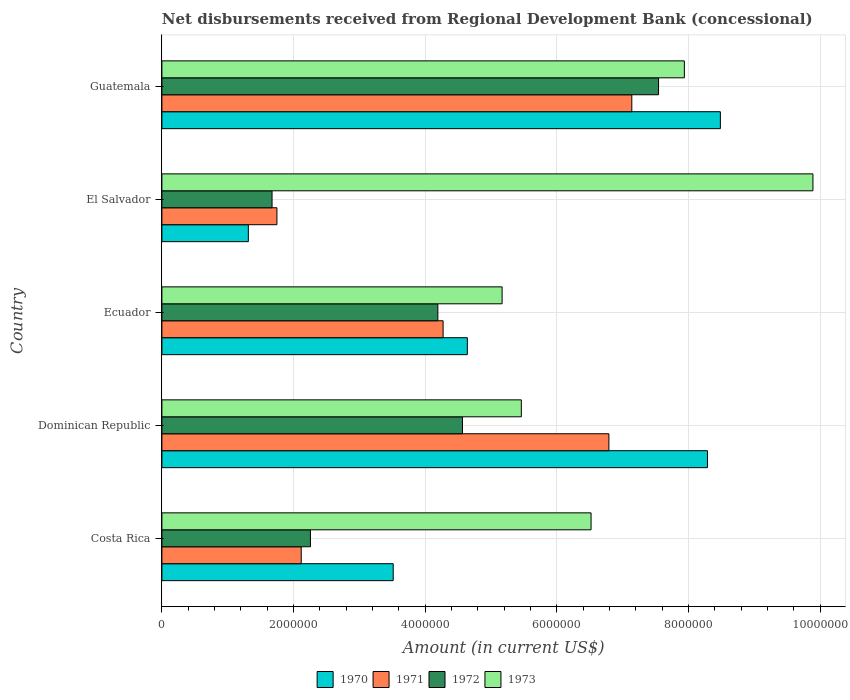How many groups of bars are there?
Give a very brief answer. 5. What is the label of the 1st group of bars from the top?
Make the answer very short. Guatemala. In how many cases, is the number of bars for a given country not equal to the number of legend labels?
Give a very brief answer. 0. What is the amount of disbursements received from Regional Development Bank in 1973 in Dominican Republic?
Keep it short and to the point. 5.46e+06. Across all countries, what is the maximum amount of disbursements received from Regional Development Bank in 1973?
Your response must be concise. 9.89e+06. Across all countries, what is the minimum amount of disbursements received from Regional Development Bank in 1973?
Provide a short and direct response. 5.17e+06. In which country was the amount of disbursements received from Regional Development Bank in 1973 maximum?
Offer a terse response. El Salvador. In which country was the amount of disbursements received from Regional Development Bank in 1971 minimum?
Make the answer very short. El Salvador. What is the total amount of disbursements received from Regional Development Bank in 1973 in the graph?
Ensure brevity in your answer.  3.50e+07. What is the difference between the amount of disbursements received from Regional Development Bank in 1973 in Costa Rica and that in Dominican Republic?
Offer a very short reply. 1.06e+06. What is the difference between the amount of disbursements received from Regional Development Bank in 1973 in Dominican Republic and the amount of disbursements received from Regional Development Bank in 1971 in El Salvador?
Your response must be concise. 3.71e+06. What is the average amount of disbursements received from Regional Development Bank in 1971 per country?
Your answer should be compact. 4.41e+06. What is the difference between the amount of disbursements received from Regional Development Bank in 1972 and amount of disbursements received from Regional Development Bank in 1970 in Guatemala?
Give a very brief answer. -9.39e+05. What is the ratio of the amount of disbursements received from Regional Development Bank in 1973 in El Salvador to that in Guatemala?
Provide a short and direct response. 1.25. Is the amount of disbursements received from Regional Development Bank in 1972 in Costa Rica less than that in Guatemala?
Give a very brief answer. Yes. Is the difference between the amount of disbursements received from Regional Development Bank in 1972 in Dominican Republic and El Salvador greater than the difference between the amount of disbursements received from Regional Development Bank in 1970 in Dominican Republic and El Salvador?
Your answer should be compact. No. What is the difference between the highest and the second highest amount of disbursements received from Regional Development Bank in 1973?
Provide a short and direct response. 1.95e+06. What is the difference between the highest and the lowest amount of disbursements received from Regional Development Bank in 1972?
Ensure brevity in your answer.  5.87e+06. In how many countries, is the amount of disbursements received from Regional Development Bank in 1970 greater than the average amount of disbursements received from Regional Development Bank in 1970 taken over all countries?
Your response must be concise. 2. Is it the case that in every country, the sum of the amount of disbursements received from Regional Development Bank in 1971 and amount of disbursements received from Regional Development Bank in 1972 is greater than the amount of disbursements received from Regional Development Bank in 1973?
Provide a succinct answer. No. How many bars are there?
Offer a terse response. 20. What is the difference between two consecutive major ticks on the X-axis?
Provide a succinct answer. 2.00e+06. Does the graph contain any zero values?
Provide a short and direct response. No. Where does the legend appear in the graph?
Offer a very short reply. Bottom center. How many legend labels are there?
Keep it short and to the point. 4. What is the title of the graph?
Your response must be concise. Net disbursements received from Regional Development Bank (concessional). What is the label or title of the X-axis?
Your answer should be compact. Amount (in current US$). What is the label or title of the Y-axis?
Provide a succinct answer. Country. What is the Amount (in current US$) in 1970 in Costa Rica?
Give a very brief answer. 3.51e+06. What is the Amount (in current US$) of 1971 in Costa Rica?
Give a very brief answer. 2.12e+06. What is the Amount (in current US$) in 1972 in Costa Rica?
Offer a terse response. 2.26e+06. What is the Amount (in current US$) in 1973 in Costa Rica?
Your answer should be compact. 6.52e+06. What is the Amount (in current US$) of 1970 in Dominican Republic?
Offer a terse response. 8.29e+06. What is the Amount (in current US$) of 1971 in Dominican Republic?
Provide a succinct answer. 6.79e+06. What is the Amount (in current US$) of 1972 in Dominican Republic?
Ensure brevity in your answer.  4.56e+06. What is the Amount (in current US$) of 1973 in Dominican Republic?
Give a very brief answer. 5.46e+06. What is the Amount (in current US$) of 1970 in Ecuador?
Ensure brevity in your answer.  4.64e+06. What is the Amount (in current US$) of 1971 in Ecuador?
Keep it short and to the point. 4.27e+06. What is the Amount (in current US$) of 1972 in Ecuador?
Your response must be concise. 4.19e+06. What is the Amount (in current US$) of 1973 in Ecuador?
Keep it short and to the point. 5.17e+06. What is the Amount (in current US$) in 1970 in El Salvador?
Give a very brief answer. 1.31e+06. What is the Amount (in current US$) in 1971 in El Salvador?
Offer a terse response. 1.75e+06. What is the Amount (in current US$) in 1972 in El Salvador?
Give a very brief answer. 1.67e+06. What is the Amount (in current US$) of 1973 in El Salvador?
Keep it short and to the point. 9.89e+06. What is the Amount (in current US$) in 1970 in Guatemala?
Your response must be concise. 8.48e+06. What is the Amount (in current US$) in 1971 in Guatemala?
Your answer should be very brief. 7.14e+06. What is the Amount (in current US$) in 1972 in Guatemala?
Your answer should be very brief. 7.54e+06. What is the Amount (in current US$) of 1973 in Guatemala?
Offer a terse response. 7.94e+06. Across all countries, what is the maximum Amount (in current US$) of 1970?
Ensure brevity in your answer.  8.48e+06. Across all countries, what is the maximum Amount (in current US$) in 1971?
Keep it short and to the point. 7.14e+06. Across all countries, what is the maximum Amount (in current US$) of 1972?
Offer a very short reply. 7.54e+06. Across all countries, what is the maximum Amount (in current US$) in 1973?
Give a very brief answer. 9.89e+06. Across all countries, what is the minimum Amount (in current US$) in 1970?
Give a very brief answer. 1.31e+06. Across all countries, what is the minimum Amount (in current US$) in 1971?
Keep it short and to the point. 1.75e+06. Across all countries, what is the minimum Amount (in current US$) of 1972?
Ensure brevity in your answer.  1.67e+06. Across all countries, what is the minimum Amount (in current US$) of 1973?
Give a very brief answer. 5.17e+06. What is the total Amount (in current US$) of 1970 in the graph?
Offer a terse response. 2.62e+07. What is the total Amount (in current US$) of 1971 in the graph?
Make the answer very short. 2.21e+07. What is the total Amount (in current US$) of 1972 in the graph?
Provide a succinct answer. 2.02e+07. What is the total Amount (in current US$) in 1973 in the graph?
Offer a very short reply. 3.50e+07. What is the difference between the Amount (in current US$) in 1970 in Costa Rica and that in Dominican Republic?
Make the answer very short. -4.77e+06. What is the difference between the Amount (in current US$) in 1971 in Costa Rica and that in Dominican Republic?
Your answer should be very brief. -4.67e+06. What is the difference between the Amount (in current US$) in 1972 in Costa Rica and that in Dominican Republic?
Offer a terse response. -2.31e+06. What is the difference between the Amount (in current US$) in 1973 in Costa Rica and that in Dominican Republic?
Provide a short and direct response. 1.06e+06. What is the difference between the Amount (in current US$) of 1970 in Costa Rica and that in Ecuador?
Make the answer very short. -1.13e+06. What is the difference between the Amount (in current US$) in 1971 in Costa Rica and that in Ecuador?
Ensure brevity in your answer.  -2.16e+06. What is the difference between the Amount (in current US$) of 1972 in Costa Rica and that in Ecuador?
Make the answer very short. -1.94e+06. What is the difference between the Amount (in current US$) in 1973 in Costa Rica and that in Ecuador?
Give a very brief answer. 1.35e+06. What is the difference between the Amount (in current US$) in 1970 in Costa Rica and that in El Salvador?
Keep it short and to the point. 2.20e+06. What is the difference between the Amount (in current US$) in 1971 in Costa Rica and that in El Salvador?
Provide a succinct answer. 3.69e+05. What is the difference between the Amount (in current US$) in 1972 in Costa Rica and that in El Salvador?
Keep it short and to the point. 5.83e+05. What is the difference between the Amount (in current US$) of 1973 in Costa Rica and that in El Salvador?
Your response must be concise. -3.37e+06. What is the difference between the Amount (in current US$) in 1970 in Costa Rica and that in Guatemala?
Your answer should be very brief. -4.97e+06. What is the difference between the Amount (in current US$) in 1971 in Costa Rica and that in Guatemala?
Make the answer very short. -5.02e+06. What is the difference between the Amount (in current US$) of 1972 in Costa Rica and that in Guatemala?
Make the answer very short. -5.29e+06. What is the difference between the Amount (in current US$) in 1973 in Costa Rica and that in Guatemala?
Offer a terse response. -1.42e+06. What is the difference between the Amount (in current US$) in 1970 in Dominican Republic and that in Ecuador?
Offer a very short reply. 3.65e+06. What is the difference between the Amount (in current US$) in 1971 in Dominican Republic and that in Ecuador?
Your answer should be very brief. 2.52e+06. What is the difference between the Amount (in current US$) in 1972 in Dominican Republic and that in Ecuador?
Give a very brief answer. 3.74e+05. What is the difference between the Amount (in current US$) of 1973 in Dominican Republic and that in Ecuador?
Offer a terse response. 2.92e+05. What is the difference between the Amount (in current US$) in 1970 in Dominican Republic and that in El Salvador?
Offer a very short reply. 6.97e+06. What is the difference between the Amount (in current US$) of 1971 in Dominican Republic and that in El Salvador?
Offer a terse response. 5.04e+06. What is the difference between the Amount (in current US$) of 1972 in Dominican Republic and that in El Salvador?
Your response must be concise. 2.89e+06. What is the difference between the Amount (in current US$) in 1973 in Dominican Republic and that in El Salvador?
Your answer should be compact. -4.43e+06. What is the difference between the Amount (in current US$) of 1970 in Dominican Republic and that in Guatemala?
Give a very brief answer. -1.96e+05. What is the difference between the Amount (in current US$) in 1971 in Dominican Republic and that in Guatemala?
Your answer should be very brief. -3.48e+05. What is the difference between the Amount (in current US$) in 1972 in Dominican Republic and that in Guatemala?
Provide a short and direct response. -2.98e+06. What is the difference between the Amount (in current US$) of 1973 in Dominican Republic and that in Guatemala?
Make the answer very short. -2.48e+06. What is the difference between the Amount (in current US$) in 1970 in Ecuador and that in El Salvador?
Your answer should be very brief. 3.33e+06. What is the difference between the Amount (in current US$) of 1971 in Ecuador and that in El Salvador?
Ensure brevity in your answer.  2.52e+06. What is the difference between the Amount (in current US$) in 1972 in Ecuador and that in El Salvador?
Offer a terse response. 2.52e+06. What is the difference between the Amount (in current US$) in 1973 in Ecuador and that in El Salvador?
Ensure brevity in your answer.  -4.72e+06. What is the difference between the Amount (in current US$) in 1970 in Ecuador and that in Guatemala?
Ensure brevity in your answer.  -3.84e+06. What is the difference between the Amount (in current US$) in 1971 in Ecuador and that in Guatemala?
Offer a very short reply. -2.87e+06. What is the difference between the Amount (in current US$) in 1972 in Ecuador and that in Guatemala?
Offer a very short reply. -3.35e+06. What is the difference between the Amount (in current US$) in 1973 in Ecuador and that in Guatemala?
Offer a terse response. -2.77e+06. What is the difference between the Amount (in current US$) in 1970 in El Salvador and that in Guatemala?
Your answer should be very brief. -7.17e+06. What is the difference between the Amount (in current US$) in 1971 in El Salvador and that in Guatemala?
Make the answer very short. -5.39e+06. What is the difference between the Amount (in current US$) in 1972 in El Salvador and that in Guatemala?
Your answer should be very brief. -5.87e+06. What is the difference between the Amount (in current US$) of 1973 in El Salvador and that in Guatemala?
Your response must be concise. 1.95e+06. What is the difference between the Amount (in current US$) in 1970 in Costa Rica and the Amount (in current US$) in 1971 in Dominican Republic?
Provide a succinct answer. -3.28e+06. What is the difference between the Amount (in current US$) of 1970 in Costa Rica and the Amount (in current US$) of 1972 in Dominican Republic?
Your answer should be very brief. -1.05e+06. What is the difference between the Amount (in current US$) of 1970 in Costa Rica and the Amount (in current US$) of 1973 in Dominican Republic?
Your answer should be compact. -1.95e+06. What is the difference between the Amount (in current US$) in 1971 in Costa Rica and the Amount (in current US$) in 1972 in Dominican Republic?
Give a very brief answer. -2.45e+06. What is the difference between the Amount (in current US$) in 1971 in Costa Rica and the Amount (in current US$) in 1973 in Dominican Republic?
Ensure brevity in your answer.  -3.34e+06. What is the difference between the Amount (in current US$) in 1972 in Costa Rica and the Amount (in current US$) in 1973 in Dominican Republic?
Give a very brief answer. -3.20e+06. What is the difference between the Amount (in current US$) of 1970 in Costa Rica and the Amount (in current US$) of 1971 in Ecuador?
Give a very brief answer. -7.58e+05. What is the difference between the Amount (in current US$) of 1970 in Costa Rica and the Amount (in current US$) of 1972 in Ecuador?
Your answer should be very brief. -6.78e+05. What is the difference between the Amount (in current US$) in 1970 in Costa Rica and the Amount (in current US$) in 1973 in Ecuador?
Ensure brevity in your answer.  -1.65e+06. What is the difference between the Amount (in current US$) in 1971 in Costa Rica and the Amount (in current US$) in 1972 in Ecuador?
Offer a very short reply. -2.08e+06. What is the difference between the Amount (in current US$) in 1971 in Costa Rica and the Amount (in current US$) in 1973 in Ecuador?
Offer a terse response. -3.05e+06. What is the difference between the Amount (in current US$) of 1972 in Costa Rica and the Amount (in current US$) of 1973 in Ecuador?
Your response must be concise. -2.91e+06. What is the difference between the Amount (in current US$) in 1970 in Costa Rica and the Amount (in current US$) in 1971 in El Salvador?
Keep it short and to the point. 1.77e+06. What is the difference between the Amount (in current US$) in 1970 in Costa Rica and the Amount (in current US$) in 1972 in El Salvador?
Your answer should be compact. 1.84e+06. What is the difference between the Amount (in current US$) of 1970 in Costa Rica and the Amount (in current US$) of 1973 in El Salvador?
Your answer should be very brief. -6.38e+06. What is the difference between the Amount (in current US$) in 1971 in Costa Rica and the Amount (in current US$) in 1972 in El Salvador?
Your answer should be very brief. 4.43e+05. What is the difference between the Amount (in current US$) in 1971 in Costa Rica and the Amount (in current US$) in 1973 in El Salvador?
Give a very brief answer. -7.77e+06. What is the difference between the Amount (in current US$) of 1972 in Costa Rica and the Amount (in current US$) of 1973 in El Salvador?
Provide a succinct answer. -7.63e+06. What is the difference between the Amount (in current US$) in 1970 in Costa Rica and the Amount (in current US$) in 1971 in Guatemala?
Give a very brief answer. -3.62e+06. What is the difference between the Amount (in current US$) of 1970 in Costa Rica and the Amount (in current US$) of 1972 in Guatemala?
Your answer should be compact. -4.03e+06. What is the difference between the Amount (in current US$) of 1970 in Costa Rica and the Amount (in current US$) of 1973 in Guatemala?
Provide a succinct answer. -4.42e+06. What is the difference between the Amount (in current US$) in 1971 in Costa Rica and the Amount (in current US$) in 1972 in Guatemala?
Your response must be concise. -5.43e+06. What is the difference between the Amount (in current US$) of 1971 in Costa Rica and the Amount (in current US$) of 1973 in Guatemala?
Offer a terse response. -5.82e+06. What is the difference between the Amount (in current US$) of 1972 in Costa Rica and the Amount (in current US$) of 1973 in Guatemala?
Provide a succinct answer. -5.68e+06. What is the difference between the Amount (in current US$) in 1970 in Dominican Republic and the Amount (in current US$) in 1971 in Ecuador?
Offer a very short reply. 4.02e+06. What is the difference between the Amount (in current US$) of 1970 in Dominican Republic and the Amount (in current US$) of 1972 in Ecuador?
Give a very brief answer. 4.10e+06. What is the difference between the Amount (in current US$) of 1970 in Dominican Republic and the Amount (in current US$) of 1973 in Ecuador?
Provide a succinct answer. 3.12e+06. What is the difference between the Amount (in current US$) in 1971 in Dominican Republic and the Amount (in current US$) in 1972 in Ecuador?
Provide a succinct answer. 2.60e+06. What is the difference between the Amount (in current US$) in 1971 in Dominican Republic and the Amount (in current US$) in 1973 in Ecuador?
Ensure brevity in your answer.  1.62e+06. What is the difference between the Amount (in current US$) in 1972 in Dominican Republic and the Amount (in current US$) in 1973 in Ecuador?
Give a very brief answer. -6.02e+05. What is the difference between the Amount (in current US$) of 1970 in Dominican Republic and the Amount (in current US$) of 1971 in El Salvador?
Ensure brevity in your answer.  6.54e+06. What is the difference between the Amount (in current US$) in 1970 in Dominican Republic and the Amount (in current US$) in 1972 in El Salvador?
Your answer should be compact. 6.61e+06. What is the difference between the Amount (in current US$) of 1970 in Dominican Republic and the Amount (in current US$) of 1973 in El Salvador?
Give a very brief answer. -1.60e+06. What is the difference between the Amount (in current US$) of 1971 in Dominican Republic and the Amount (in current US$) of 1972 in El Salvador?
Offer a terse response. 5.12e+06. What is the difference between the Amount (in current US$) in 1971 in Dominican Republic and the Amount (in current US$) in 1973 in El Salvador?
Make the answer very short. -3.10e+06. What is the difference between the Amount (in current US$) in 1972 in Dominican Republic and the Amount (in current US$) in 1973 in El Salvador?
Your answer should be very brief. -5.32e+06. What is the difference between the Amount (in current US$) in 1970 in Dominican Republic and the Amount (in current US$) in 1971 in Guatemala?
Offer a terse response. 1.15e+06. What is the difference between the Amount (in current US$) in 1970 in Dominican Republic and the Amount (in current US$) in 1972 in Guatemala?
Keep it short and to the point. 7.43e+05. What is the difference between the Amount (in current US$) of 1970 in Dominican Republic and the Amount (in current US$) of 1973 in Guatemala?
Your response must be concise. 3.51e+05. What is the difference between the Amount (in current US$) in 1971 in Dominican Republic and the Amount (in current US$) in 1972 in Guatemala?
Your answer should be compact. -7.54e+05. What is the difference between the Amount (in current US$) in 1971 in Dominican Republic and the Amount (in current US$) in 1973 in Guatemala?
Give a very brief answer. -1.15e+06. What is the difference between the Amount (in current US$) of 1972 in Dominican Republic and the Amount (in current US$) of 1973 in Guatemala?
Provide a short and direct response. -3.37e+06. What is the difference between the Amount (in current US$) of 1970 in Ecuador and the Amount (in current US$) of 1971 in El Salvador?
Offer a terse response. 2.89e+06. What is the difference between the Amount (in current US$) of 1970 in Ecuador and the Amount (in current US$) of 1972 in El Salvador?
Your response must be concise. 2.97e+06. What is the difference between the Amount (in current US$) of 1970 in Ecuador and the Amount (in current US$) of 1973 in El Salvador?
Offer a very short reply. -5.25e+06. What is the difference between the Amount (in current US$) in 1971 in Ecuador and the Amount (in current US$) in 1972 in El Salvador?
Provide a succinct answer. 2.60e+06. What is the difference between the Amount (in current US$) of 1971 in Ecuador and the Amount (in current US$) of 1973 in El Salvador?
Provide a short and direct response. -5.62e+06. What is the difference between the Amount (in current US$) of 1972 in Ecuador and the Amount (in current US$) of 1973 in El Salvador?
Your response must be concise. -5.70e+06. What is the difference between the Amount (in current US$) in 1970 in Ecuador and the Amount (in current US$) in 1971 in Guatemala?
Offer a terse response. -2.50e+06. What is the difference between the Amount (in current US$) of 1970 in Ecuador and the Amount (in current US$) of 1972 in Guatemala?
Your response must be concise. -2.90e+06. What is the difference between the Amount (in current US$) of 1970 in Ecuador and the Amount (in current US$) of 1973 in Guatemala?
Offer a terse response. -3.30e+06. What is the difference between the Amount (in current US$) in 1971 in Ecuador and the Amount (in current US$) in 1972 in Guatemala?
Provide a succinct answer. -3.27e+06. What is the difference between the Amount (in current US$) of 1971 in Ecuador and the Amount (in current US$) of 1973 in Guatemala?
Your answer should be very brief. -3.66e+06. What is the difference between the Amount (in current US$) of 1972 in Ecuador and the Amount (in current US$) of 1973 in Guatemala?
Provide a succinct answer. -3.74e+06. What is the difference between the Amount (in current US$) in 1970 in El Salvador and the Amount (in current US$) in 1971 in Guatemala?
Offer a terse response. -5.82e+06. What is the difference between the Amount (in current US$) of 1970 in El Salvador and the Amount (in current US$) of 1972 in Guatemala?
Your answer should be very brief. -6.23e+06. What is the difference between the Amount (in current US$) in 1970 in El Salvador and the Amount (in current US$) in 1973 in Guatemala?
Make the answer very short. -6.62e+06. What is the difference between the Amount (in current US$) in 1971 in El Salvador and the Amount (in current US$) in 1972 in Guatemala?
Your response must be concise. -5.80e+06. What is the difference between the Amount (in current US$) in 1971 in El Salvador and the Amount (in current US$) in 1973 in Guatemala?
Provide a short and direct response. -6.19e+06. What is the difference between the Amount (in current US$) in 1972 in El Salvador and the Amount (in current US$) in 1973 in Guatemala?
Your answer should be compact. -6.26e+06. What is the average Amount (in current US$) in 1970 per country?
Your response must be concise. 5.25e+06. What is the average Amount (in current US$) in 1971 per country?
Keep it short and to the point. 4.41e+06. What is the average Amount (in current US$) in 1972 per country?
Offer a very short reply. 4.05e+06. What is the average Amount (in current US$) of 1973 per country?
Your response must be concise. 6.99e+06. What is the difference between the Amount (in current US$) of 1970 and Amount (in current US$) of 1971 in Costa Rica?
Offer a terse response. 1.40e+06. What is the difference between the Amount (in current US$) in 1970 and Amount (in current US$) in 1972 in Costa Rica?
Your response must be concise. 1.26e+06. What is the difference between the Amount (in current US$) of 1970 and Amount (in current US$) of 1973 in Costa Rica?
Offer a terse response. -3.00e+06. What is the difference between the Amount (in current US$) in 1971 and Amount (in current US$) in 1972 in Costa Rica?
Your response must be concise. -1.40e+05. What is the difference between the Amount (in current US$) in 1971 and Amount (in current US$) in 1973 in Costa Rica?
Your answer should be very brief. -4.40e+06. What is the difference between the Amount (in current US$) in 1972 and Amount (in current US$) in 1973 in Costa Rica?
Provide a succinct answer. -4.26e+06. What is the difference between the Amount (in current US$) of 1970 and Amount (in current US$) of 1971 in Dominican Republic?
Offer a very short reply. 1.50e+06. What is the difference between the Amount (in current US$) in 1970 and Amount (in current US$) in 1972 in Dominican Republic?
Ensure brevity in your answer.  3.72e+06. What is the difference between the Amount (in current US$) in 1970 and Amount (in current US$) in 1973 in Dominican Republic?
Offer a terse response. 2.83e+06. What is the difference between the Amount (in current US$) of 1971 and Amount (in current US$) of 1972 in Dominican Republic?
Keep it short and to the point. 2.22e+06. What is the difference between the Amount (in current US$) of 1971 and Amount (in current US$) of 1973 in Dominican Republic?
Keep it short and to the point. 1.33e+06. What is the difference between the Amount (in current US$) of 1972 and Amount (in current US$) of 1973 in Dominican Republic?
Your answer should be very brief. -8.94e+05. What is the difference between the Amount (in current US$) in 1970 and Amount (in current US$) in 1971 in Ecuador?
Ensure brevity in your answer.  3.68e+05. What is the difference between the Amount (in current US$) in 1970 and Amount (in current US$) in 1972 in Ecuador?
Your answer should be compact. 4.48e+05. What is the difference between the Amount (in current US$) in 1970 and Amount (in current US$) in 1973 in Ecuador?
Provide a short and direct response. -5.28e+05. What is the difference between the Amount (in current US$) of 1971 and Amount (in current US$) of 1972 in Ecuador?
Offer a terse response. 8.00e+04. What is the difference between the Amount (in current US$) of 1971 and Amount (in current US$) of 1973 in Ecuador?
Offer a very short reply. -8.96e+05. What is the difference between the Amount (in current US$) of 1972 and Amount (in current US$) of 1973 in Ecuador?
Ensure brevity in your answer.  -9.76e+05. What is the difference between the Amount (in current US$) of 1970 and Amount (in current US$) of 1971 in El Salvador?
Offer a terse response. -4.34e+05. What is the difference between the Amount (in current US$) of 1970 and Amount (in current US$) of 1972 in El Salvador?
Ensure brevity in your answer.  -3.60e+05. What is the difference between the Amount (in current US$) of 1970 and Amount (in current US$) of 1973 in El Salvador?
Your answer should be compact. -8.58e+06. What is the difference between the Amount (in current US$) of 1971 and Amount (in current US$) of 1972 in El Salvador?
Make the answer very short. 7.40e+04. What is the difference between the Amount (in current US$) of 1971 and Amount (in current US$) of 1973 in El Salvador?
Ensure brevity in your answer.  -8.14e+06. What is the difference between the Amount (in current US$) in 1972 and Amount (in current US$) in 1973 in El Salvador?
Your answer should be very brief. -8.22e+06. What is the difference between the Amount (in current US$) in 1970 and Amount (in current US$) in 1971 in Guatemala?
Your answer should be compact. 1.34e+06. What is the difference between the Amount (in current US$) of 1970 and Amount (in current US$) of 1972 in Guatemala?
Keep it short and to the point. 9.39e+05. What is the difference between the Amount (in current US$) in 1970 and Amount (in current US$) in 1973 in Guatemala?
Provide a short and direct response. 5.47e+05. What is the difference between the Amount (in current US$) in 1971 and Amount (in current US$) in 1972 in Guatemala?
Offer a very short reply. -4.06e+05. What is the difference between the Amount (in current US$) in 1971 and Amount (in current US$) in 1973 in Guatemala?
Keep it short and to the point. -7.98e+05. What is the difference between the Amount (in current US$) of 1972 and Amount (in current US$) of 1973 in Guatemala?
Give a very brief answer. -3.92e+05. What is the ratio of the Amount (in current US$) in 1970 in Costa Rica to that in Dominican Republic?
Keep it short and to the point. 0.42. What is the ratio of the Amount (in current US$) in 1971 in Costa Rica to that in Dominican Republic?
Your response must be concise. 0.31. What is the ratio of the Amount (in current US$) of 1972 in Costa Rica to that in Dominican Republic?
Keep it short and to the point. 0.49. What is the ratio of the Amount (in current US$) of 1973 in Costa Rica to that in Dominican Republic?
Make the answer very short. 1.19. What is the ratio of the Amount (in current US$) of 1970 in Costa Rica to that in Ecuador?
Keep it short and to the point. 0.76. What is the ratio of the Amount (in current US$) of 1971 in Costa Rica to that in Ecuador?
Provide a succinct answer. 0.5. What is the ratio of the Amount (in current US$) in 1972 in Costa Rica to that in Ecuador?
Provide a succinct answer. 0.54. What is the ratio of the Amount (in current US$) of 1973 in Costa Rica to that in Ecuador?
Your response must be concise. 1.26. What is the ratio of the Amount (in current US$) of 1970 in Costa Rica to that in El Salvador?
Your answer should be compact. 2.68. What is the ratio of the Amount (in current US$) of 1971 in Costa Rica to that in El Salvador?
Your response must be concise. 1.21. What is the ratio of the Amount (in current US$) in 1972 in Costa Rica to that in El Salvador?
Ensure brevity in your answer.  1.35. What is the ratio of the Amount (in current US$) of 1973 in Costa Rica to that in El Salvador?
Keep it short and to the point. 0.66. What is the ratio of the Amount (in current US$) of 1970 in Costa Rica to that in Guatemala?
Make the answer very short. 0.41. What is the ratio of the Amount (in current US$) in 1971 in Costa Rica to that in Guatemala?
Your answer should be compact. 0.3. What is the ratio of the Amount (in current US$) of 1972 in Costa Rica to that in Guatemala?
Your response must be concise. 0.3. What is the ratio of the Amount (in current US$) of 1973 in Costa Rica to that in Guatemala?
Offer a terse response. 0.82. What is the ratio of the Amount (in current US$) in 1970 in Dominican Republic to that in Ecuador?
Make the answer very short. 1.79. What is the ratio of the Amount (in current US$) of 1971 in Dominican Republic to that in Ecuador?
Keep it short and to the point. 1.59. What is the ratio of the Amount (in current US$) in 1972 in Dominican Republic to that in Ecuador?
Offer a terse response. 1.09. What is the ratio of the Amount (in current US$) in 1973 in Dominican Republic to that in Ecuador?
Keep it short and to the point. 1.06. What is the ratio of the Amount (in current US$) in 1970 in Dominican Republic to that in El Salvador?
Make the answer very short. 6.31. What is the ratio of the Amount (in current US$) in 1971 in Dominican Republic to that in El Salvador?
Keep it short and to the point. 3.89. What is the ratio of the Amount (in current US$) in 1972 in Dominican Republic to that in El Salvador?
Your answer should be compact. 2.73. What is the ratio of the Amount (in current US$) of 1973 in Dominican Republic to that in El Salvador?
Your response must be concise. 0.55. What is the ratio of the Amount (in current US$) of 1970 in Dominican Republic to that in Guatemala?
Your answer should be compact. 0.98. What is the ratio of the Amount (in current US$) of 1971 in Dominican Republic to that in Guatemala?
Your answer should be compact. 0.95. What is the ratio of the Amount (in current US$) in 1972 in Dominican Republic to that in Guatemala?
Offer a very short reply. 0.61. What is the ratio of the Amount (in current US$) in 1973 in Dominican Republic to that in Guatemala?
Provide a succinct answer. 0.69. What is the ratio of the Amount (in current US$) of 1970 in Ecuador to that in El Salvador?
Keep it short and to the point. 3.53. What is the ratio of the Amount (in current US$) of 1971 in Ecuador to that in El Salvador?
Ensure brevity in your answer.  2.44. What is the ratio of the Amount (in current US$) of 1972 in Ecuador to that in El Salvador?
Give a very brief answer. 2.51. What is the ratio of the Amount (in current US$) in 1973 in Ecuador to that in El Salvador?
Make the answer very short. 0.52. What is the ratio of the Amount (in current US$) in 1970 in Ecuador to that in Guatemala?
Give a very brief answer. 0.55. What is the ratio of the Amount (in current US$) of 1971 in Ecuador to that in Guatemala?
Your answer should be compact. 0.6. What is the ratio of the Amount (in current US$) of 1972 in Ecuador to that in Guatemala?
Your response must be concise. 0.56. What is the ratio of the Amount (in current US$) in 1973 in Ecuador to that in Guatemala?
Your response must be concise. 0.65. What is the ratio of the Amount (in current US$) in 1970 in El Salvador to that in Guatemala?
Offer a terse response. 0.15. What is the ratio of the Amount (in current US$) in 1971 in El Salvador to that in Guatemala?
Your answer should be compact. 0.24. What is the ratio of the Amount (in current US$) of 1972 in El Salvador to that in Guatemala?
Your answer should be compact. 0.22. What is the ratio of the Amount (in current US$) of 1973 in El Salvador to that in Guatemala?
Your answer should be very brief. 1.25. What is the difference between the highest and the second highest Amount (in current US$) in 1970?
Provide a short and direct response. 1.96e+05. What is the difference between the highest and the second highest Amount (in current US$) of 1971?
Keep it short and to the point. 3.48e+05. What is the difference between the highest and the second highest Amount (in current US$) in 1972?
Offer a terse response. 2.98e+06. What is the difference between the highest and the second highest Amount (in current US$) of 1973?
Give a very brief answer. 1.95e+06. What is the difference between the highest and the lowest Amount (in current US$) of 1970?
Ensure brevity in your answer.  7.17e+06. What is the difference between the highest and the lowest Amount (in current US$) of 1971?
Your answer should be very brief. 5.39e+06. What is the difference between the highest and the lowest Amount (in current US$) in 1972?
Offer a terse response. 5.87e+06. What is the difference between the highest and the lowest Amount (in current US$) in 1973?
Provide a short and direct response. 4.72e+06. 